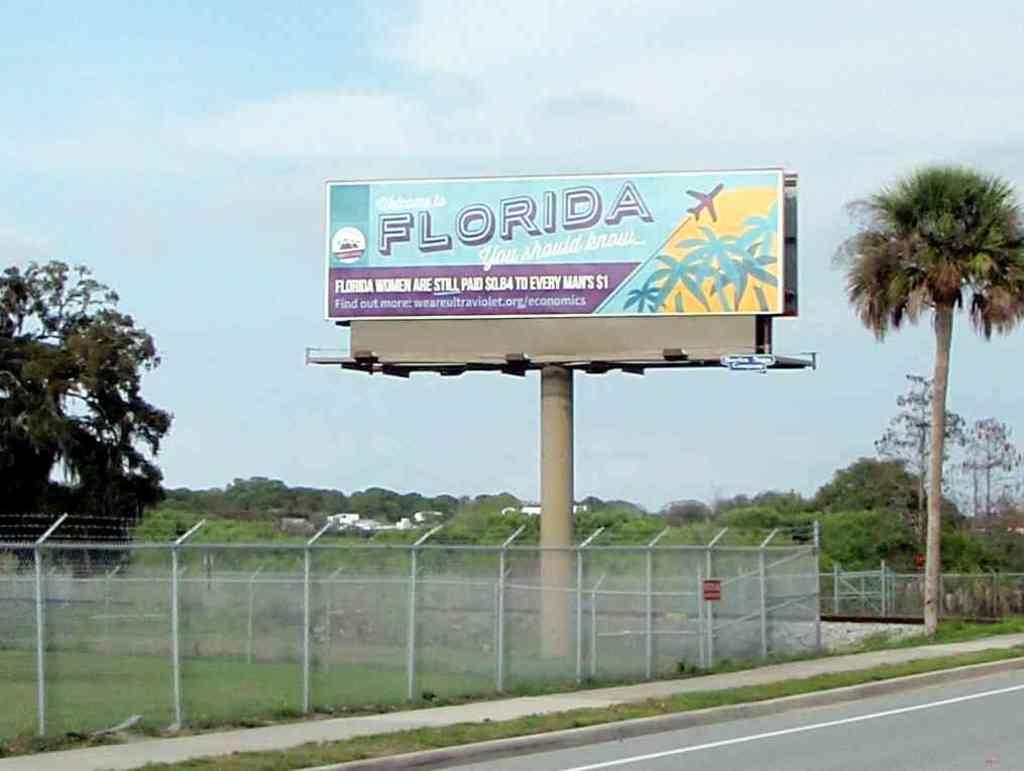What state is advertised on this billboard?
Provide a succinct answer. Florida. How much are women paid per $1 a man is paid?
Offer a terse response. $0.84. 